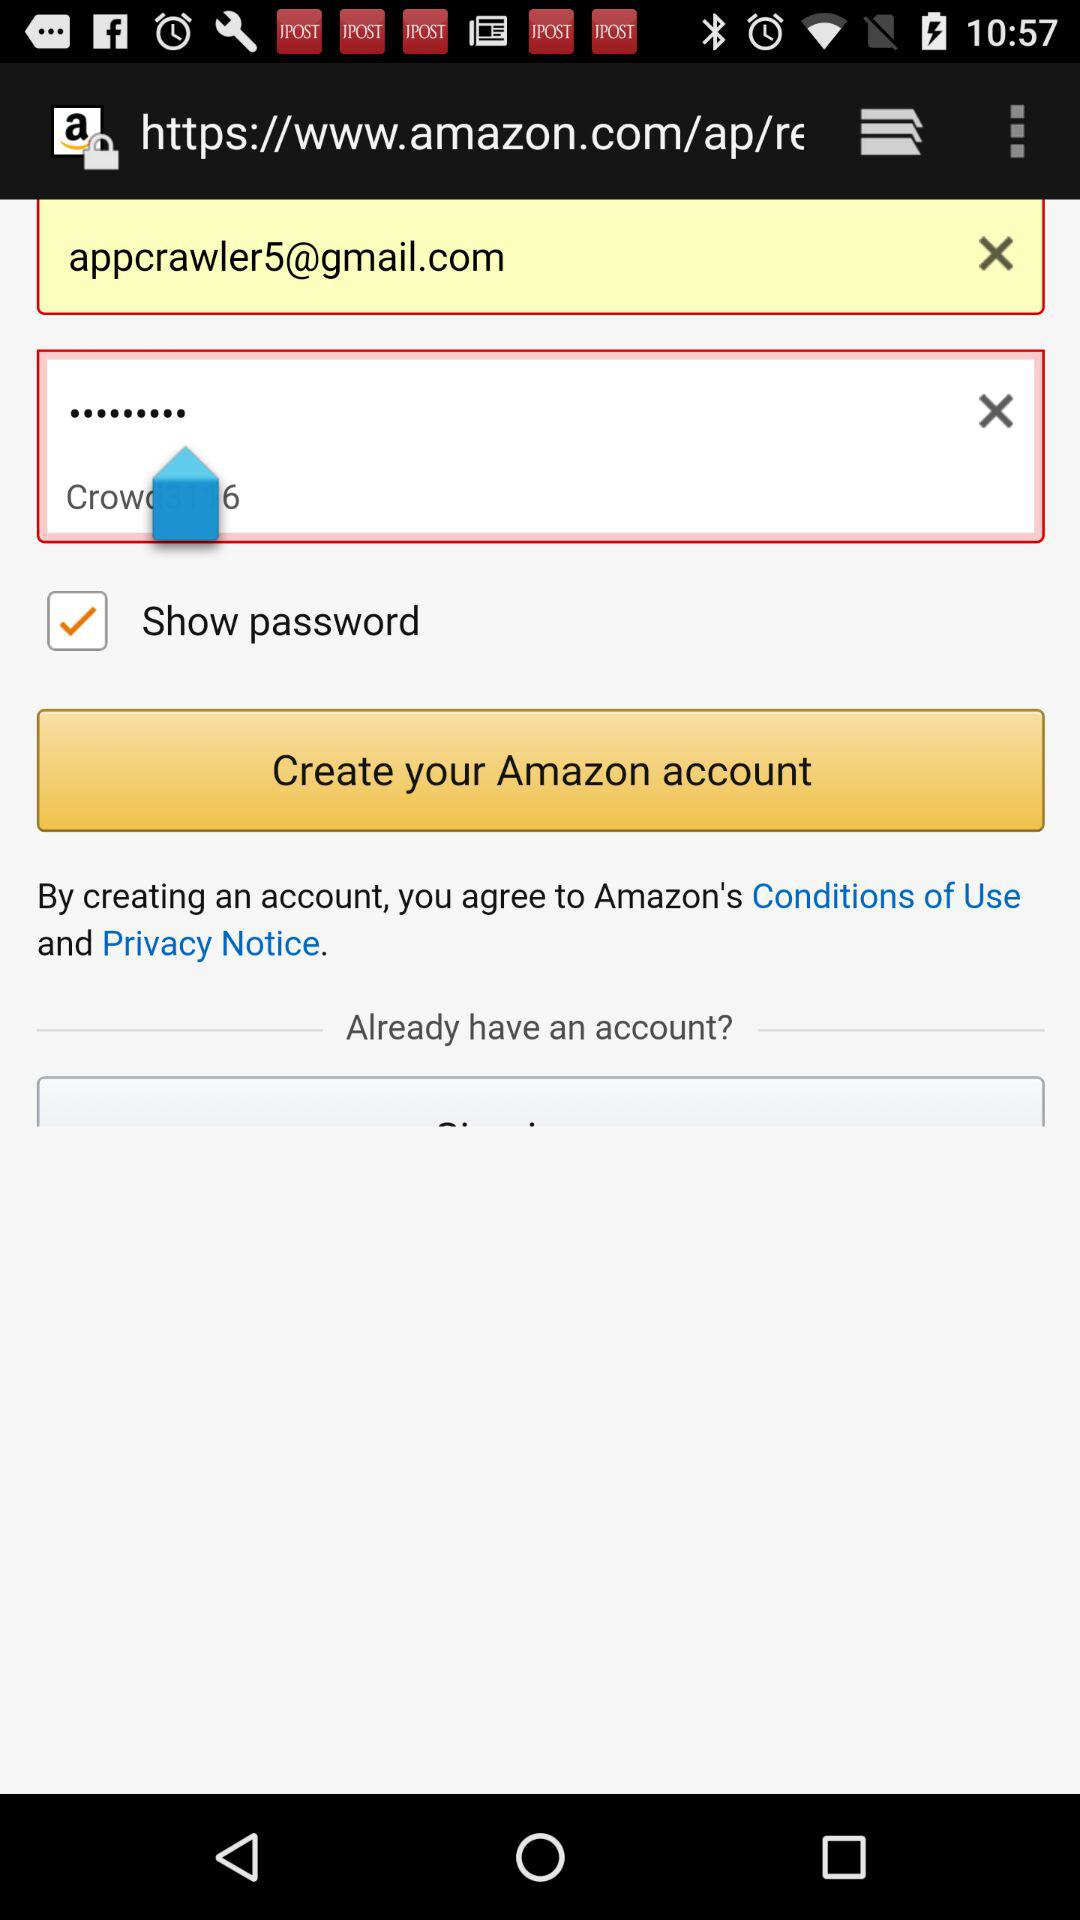What's the Google mail address used by a user to create an Amazon account? The Google mail address is appcrawler5@gmail.com. 